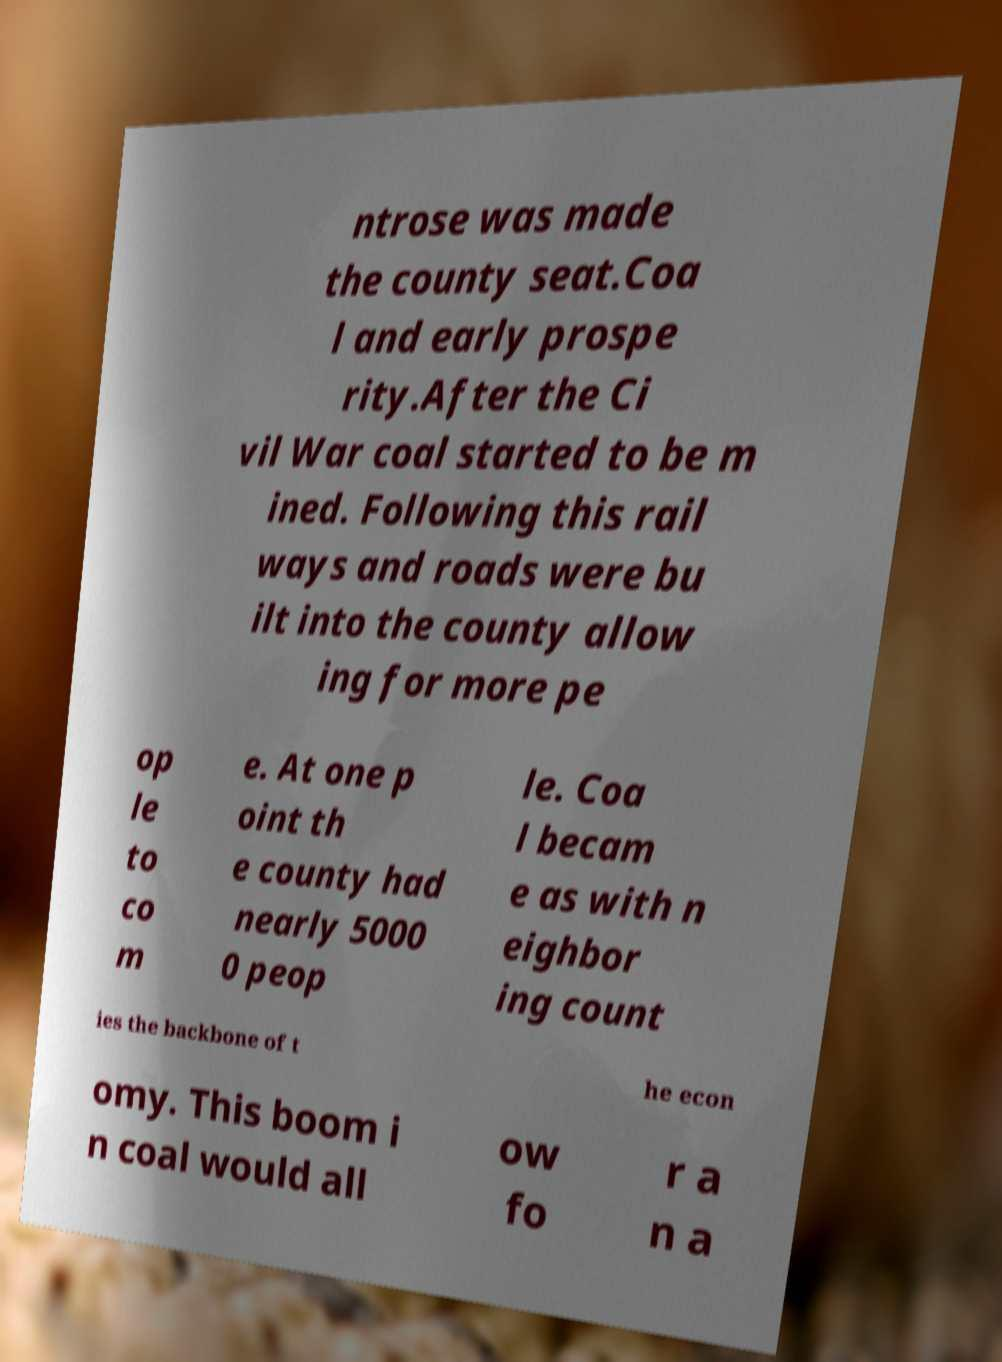I need the written content from this picture converted into text. Can you do that? ntrose was made the county seat.Coa l and early prospe rity.After the Ci vil War coal started to be m ined. Following this rail ways and roads were bu ilt into the county allow ing for more pe op le to co m e. At one p oint th e county had nearly 5000 0 peop le. Coa l becam e as with n eighbor ing count ies the backbone of t he econ omy. This boom i n coal would all ow fo r a n a 